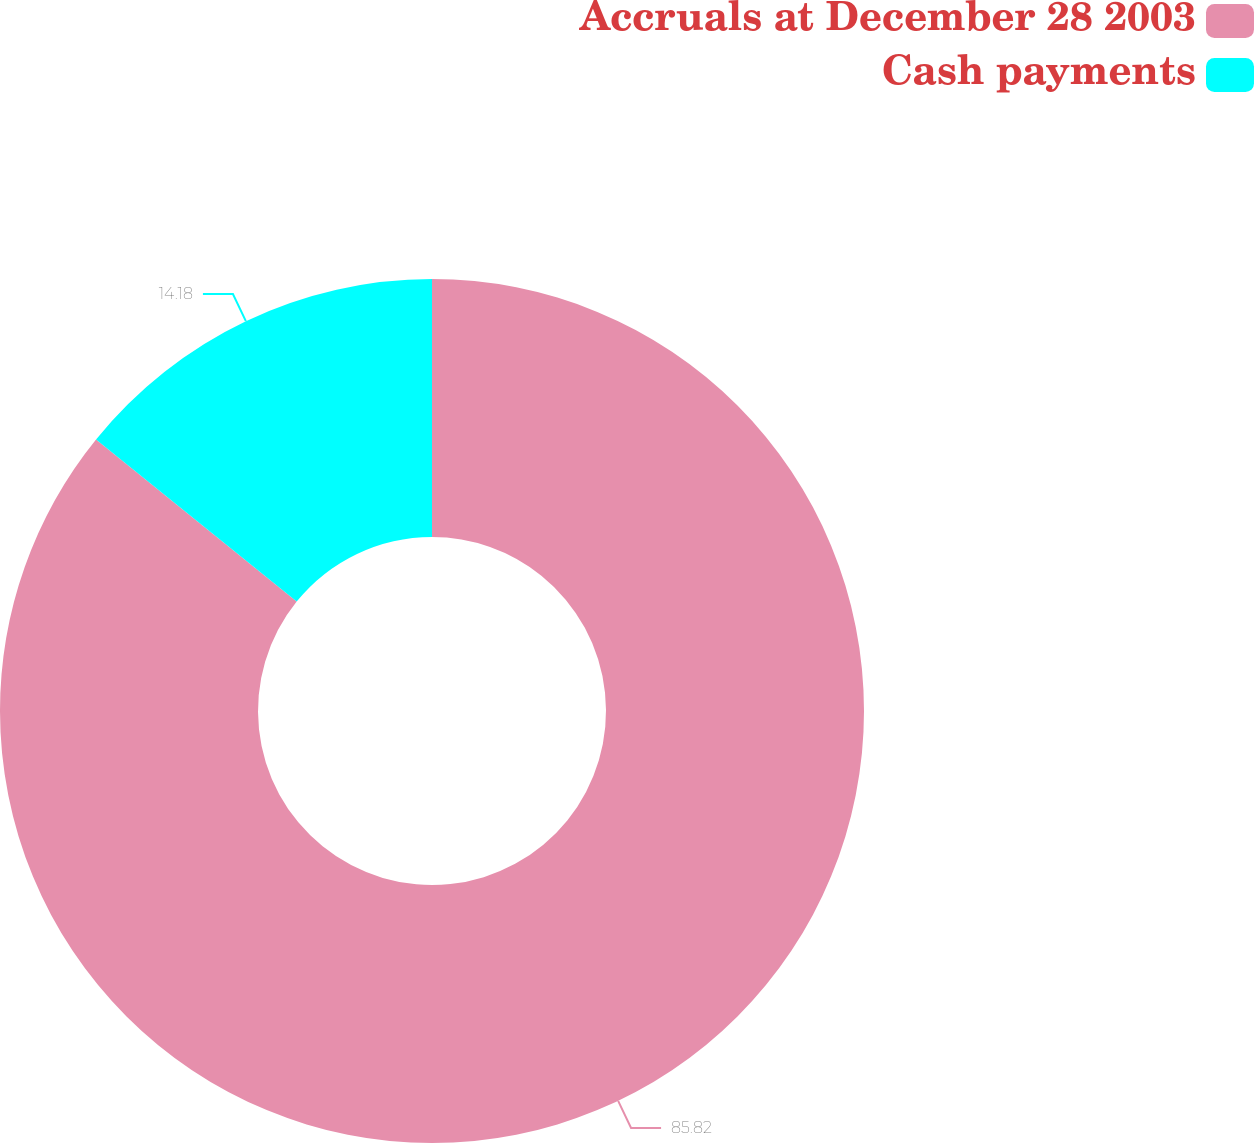<chart> <loc_0><loc_0><loc_500><loc_500><pie_chart><fcel>Accruals at December 28 2003<fcel>Cash payments<nl><fcel>85.82%<fcel>14.18%<nl></chart> 